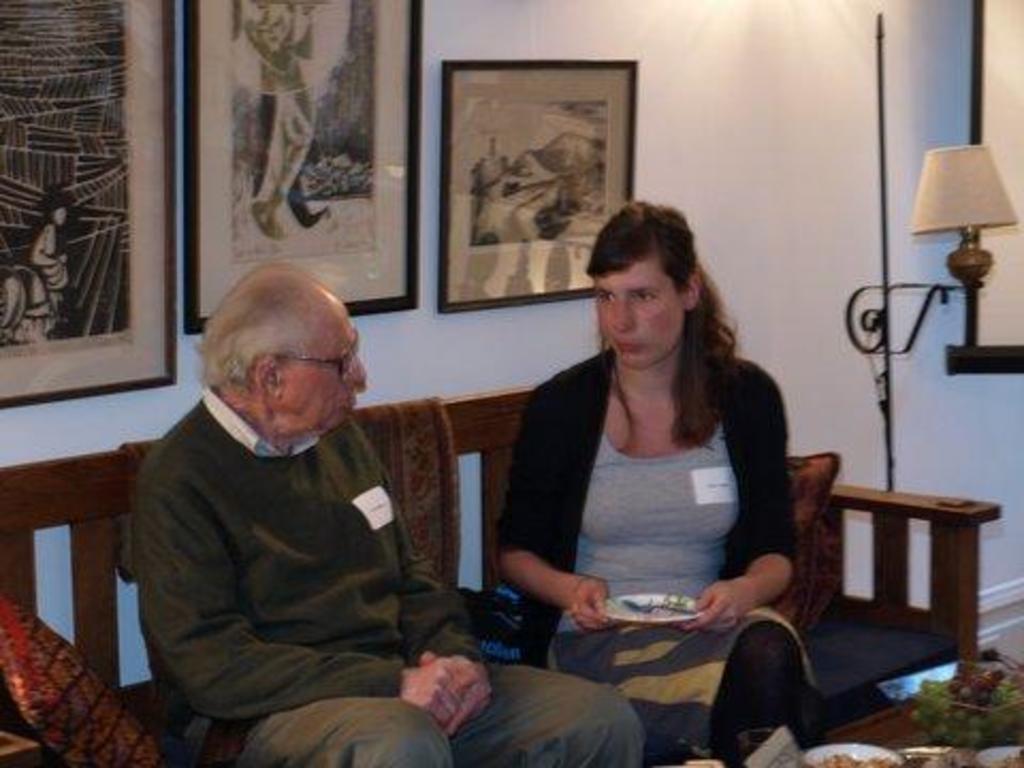Could you give a brief overview of what you see in this image? There is a person in a coat sitting on a bench near a woman who is in black color jacket holding a plate and sitting on the bench in front of a table on which, there are plates having food items, a bowl having fruits and other objects. In the background, there are photo frames on the white wall and there is a light. 